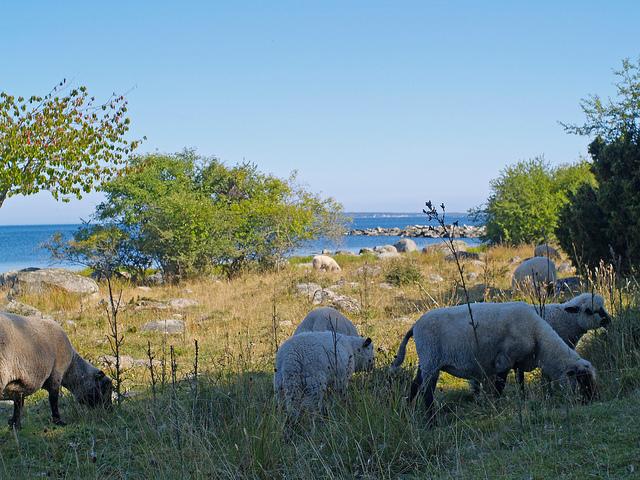What type of animals can be seen?
Give a very brief answer. Sheep. Are there more than just elephants in the picture?
Keep it brief. Yes. What many animals are in the picture?
Keep it brief. 5. What kind of animal is in the picture?
Concise answer only. Sheep. How tall is the plant?
Be succinct. 2 feet. Is there a lot of cloud coverage?
Short answer required. No. Do you see mountains?
Answer briefly. No. What are the animals doing?
Answer briefly. Grazing. 